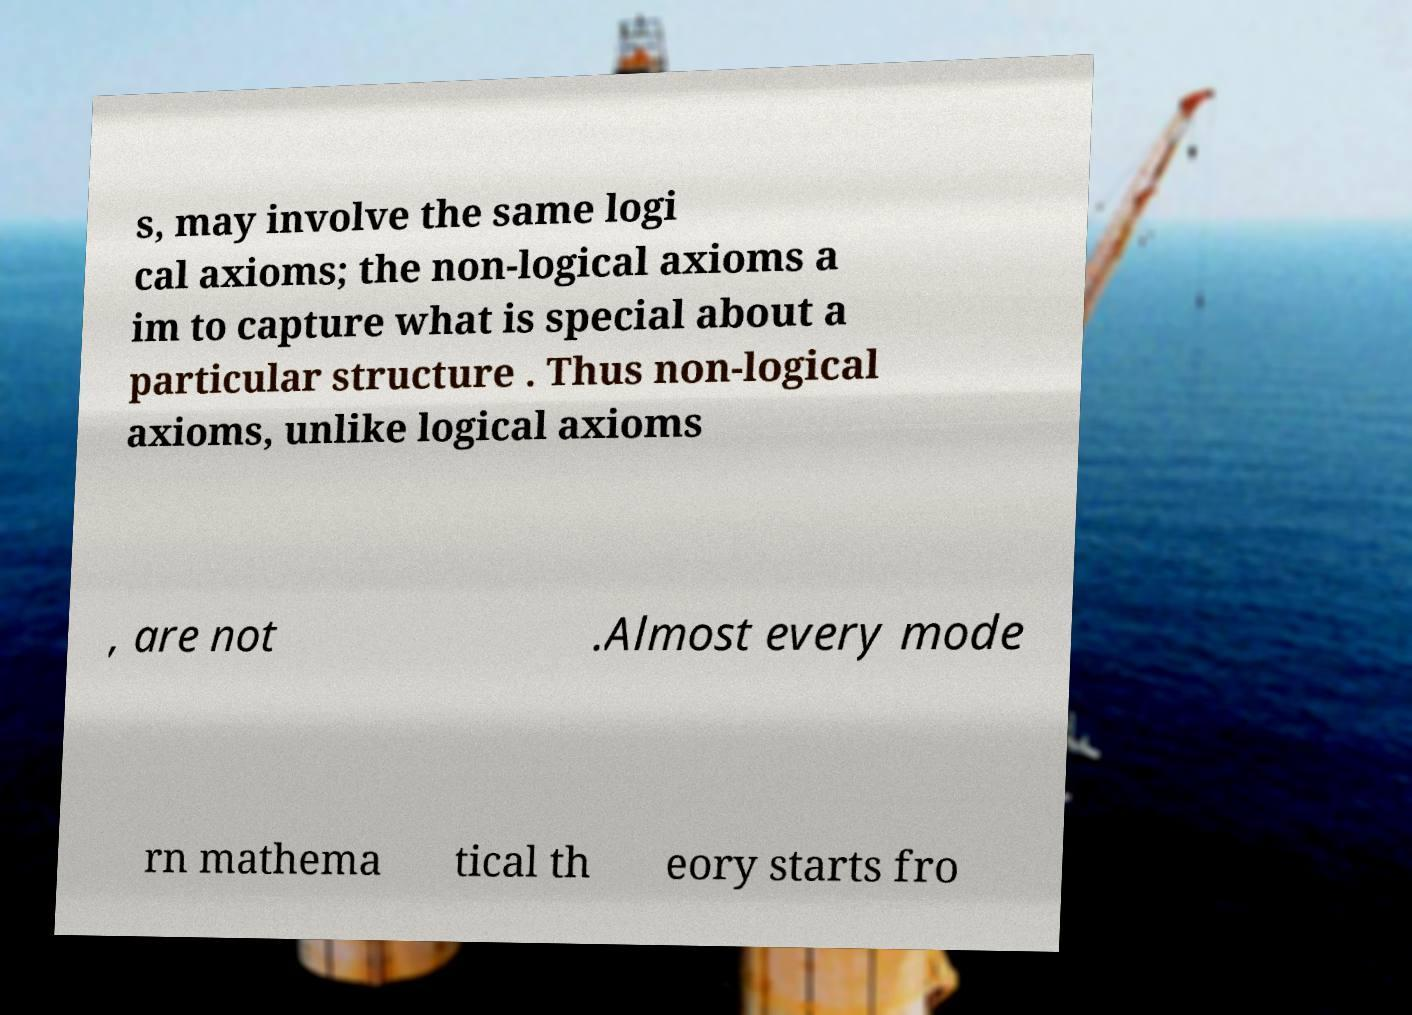Can you read and provide the text displayed in the image?This photo seems to have some interesting text. Can you extract and type it out for me? s, may involve the same logi cal axioms; the non-logical axioms a im to capture what is special about a particular structure . Thus non-logical axioms, unlike logical axioms , are not .Almost every mode rn mathema tical th eory starts fro 